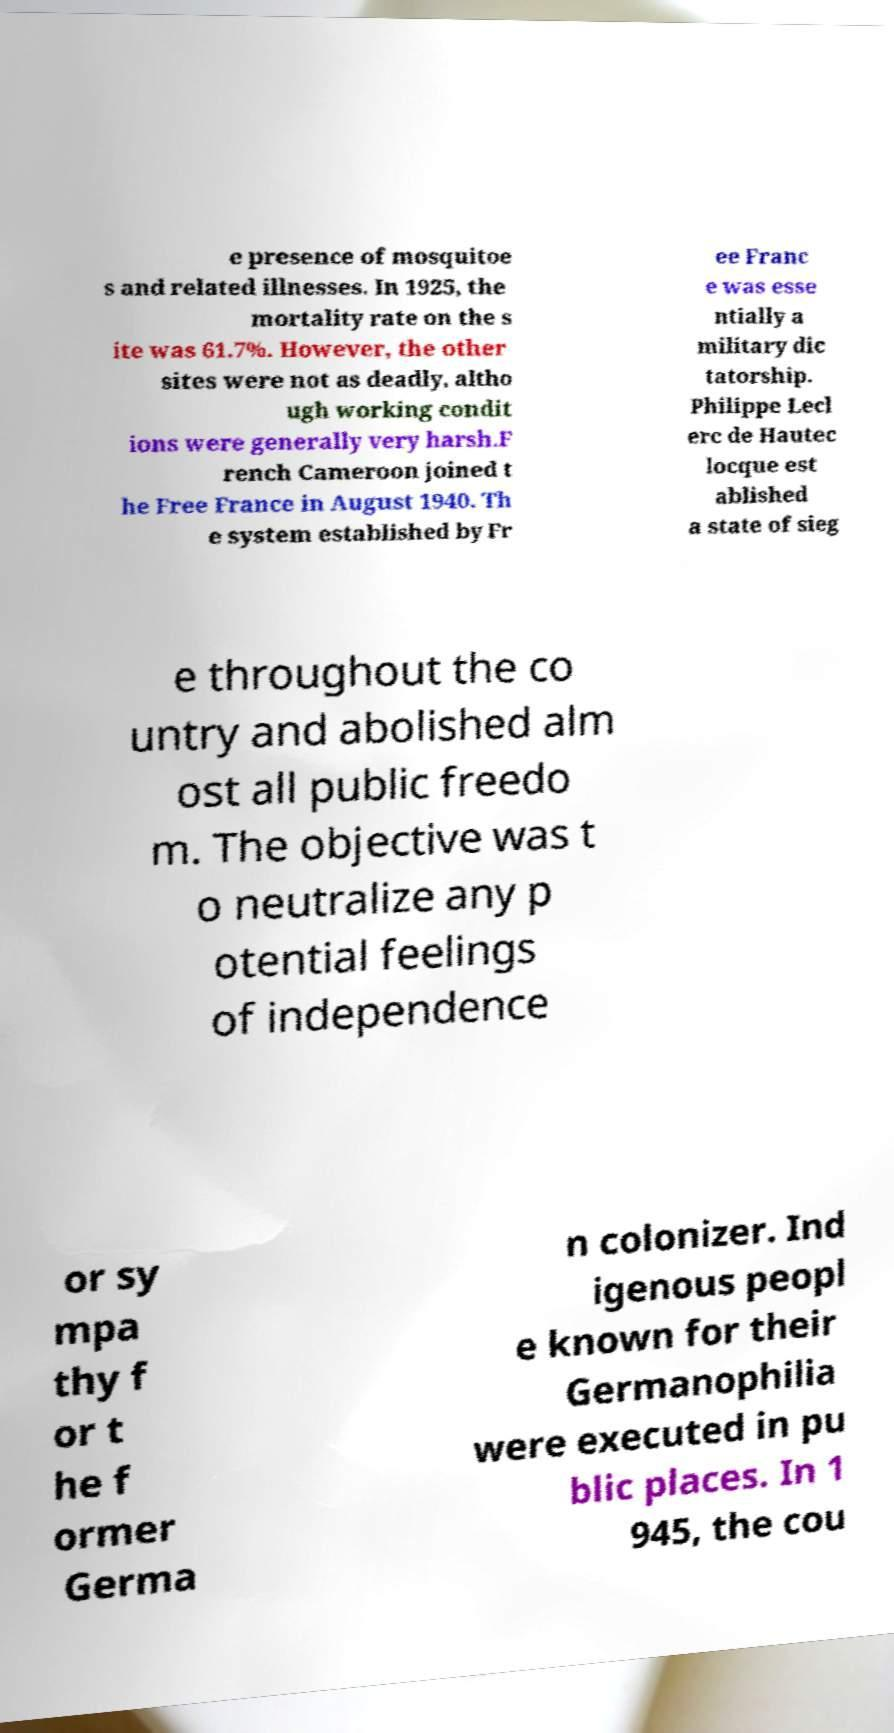I need the written content from this picture converted into text. Can you do that? e presence of mosquitoe s and related illnesses. In 1925, the mortality rate on the s ite was 61.7%. However, the other sites were not as deadly, altho ugh working condit ions were generally very harsh.F rench Cameroon joined t he Free France in August 1940. Th e system established by Fr ee Franc e was esse ntially a military dic tatorship. Philippe Lecl erc de Hautec locque est ablished a state of sieg e throughout the co untry and abolished alm ost all public freedo m. The objective was t o neutralize any p otential feelings of independence or sy mpa thy f or t he f ormer Germa n colonizer. Ind igenous peopl e known for their Germanophilia were executed in pu blic places. In 1 945, the cou 